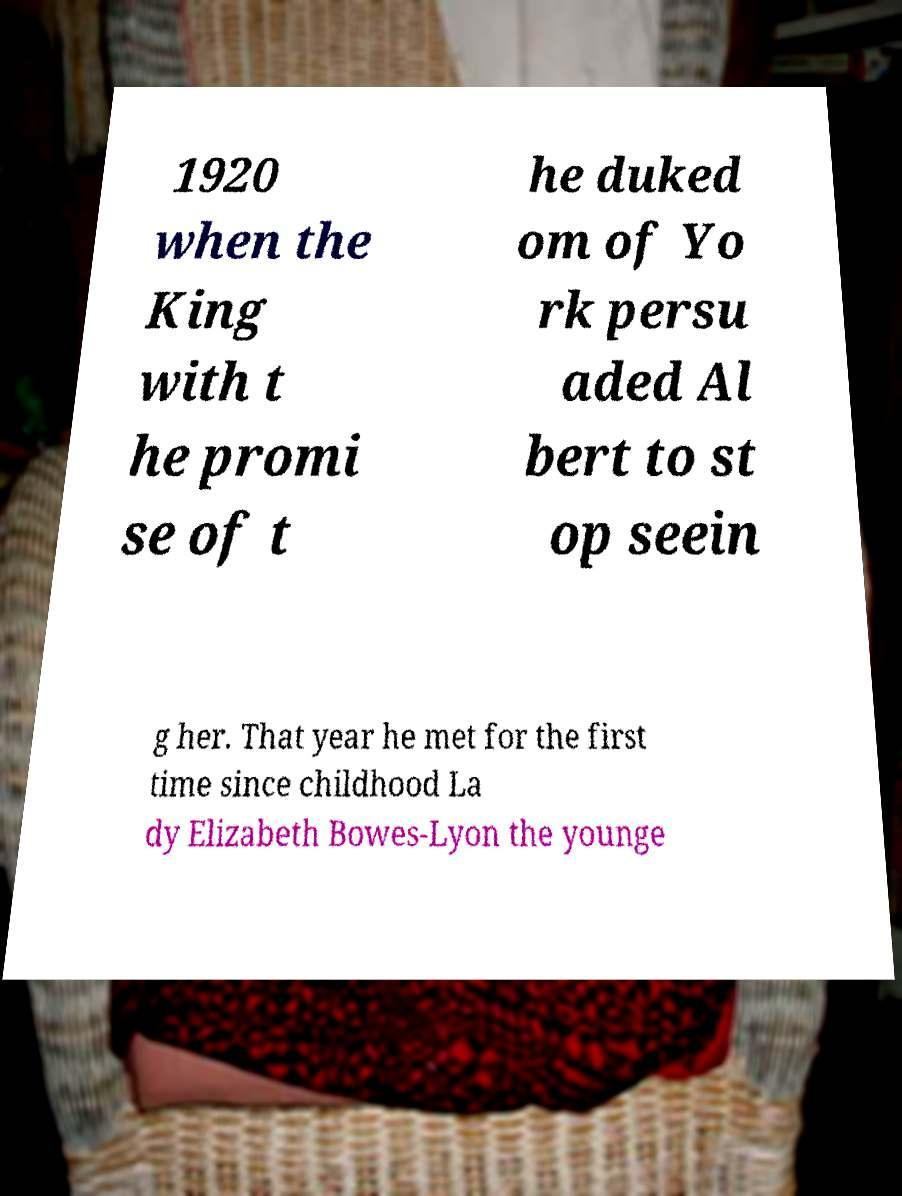What messages or text are displayed in this image? I need them in a readable, typed format. 1920 when the King with t he promi se of t he duked om of Yo rk persu aded Al bert to st op seein g her. That year he met for the first time since childhood La dy Elizabeth Bowes-Lyon the younge 